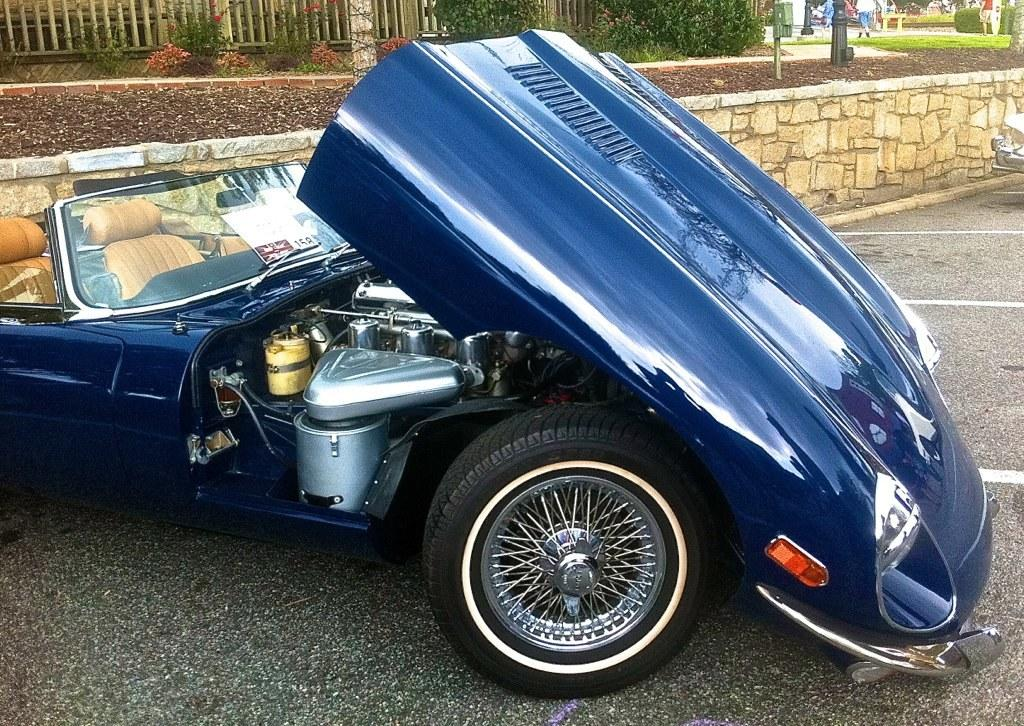What is the main subject in the center of the image? There is a vehicle in the center of the image. What is located at the bottom of the image? There is a road at the bottom of the image. What can be seen in the background of the image? There is a fence, trees, plants, and a wall in the background of the image. What type of necklace is the vehicle wearing in the image? There is no necklace present in the image, as the main subject is a vehicle. Is there an umbrella being used by the trees in the background of the image? There is no umbrella present in the image; the background features trees, plants, and a wall. 